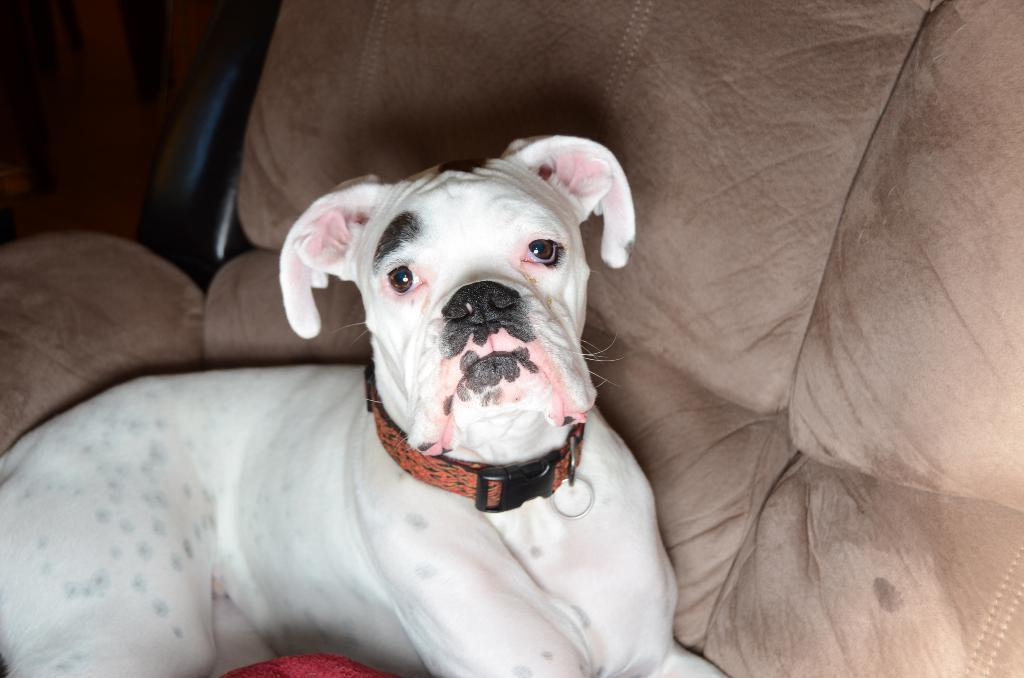What type of animal is in the image? There is a white dog in the image. What is the dog doing in the image? The dog is sitting on a couch. Can you describe the bottom part of the image? There is a cloth at the bottom of the image. What type of rice is being cooked in the image? There is no rice present in the image; it features a white dog sitting on a couch. What is the temperature like in the image? The provided facts do not mention the temperature or season, so it cannot be determined from the image. 